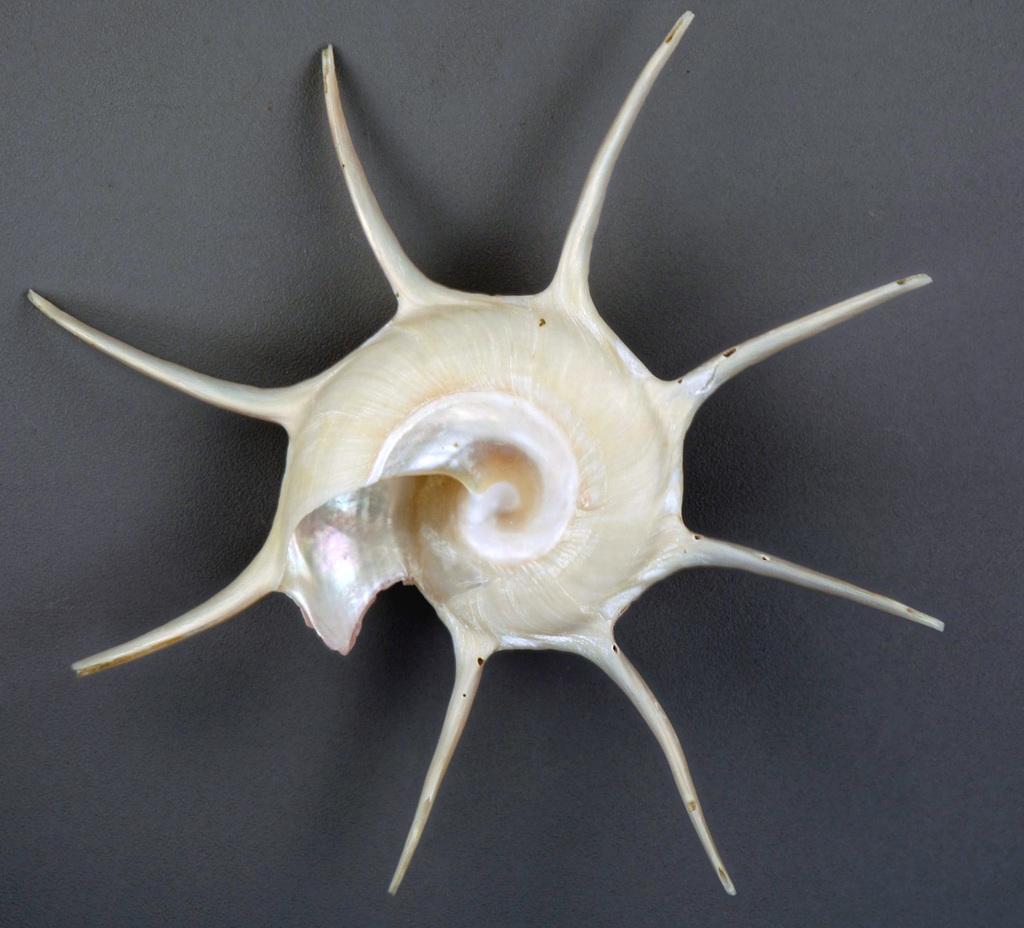How would you summarize this image in a sentence or two? There is a white color snail's cell. And the background is white in color. 